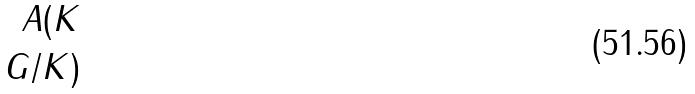Convert formula to latex. <formula><loc_0><loc_0><loc_500><loc_500>A ( K \\ G / K )</formula> 